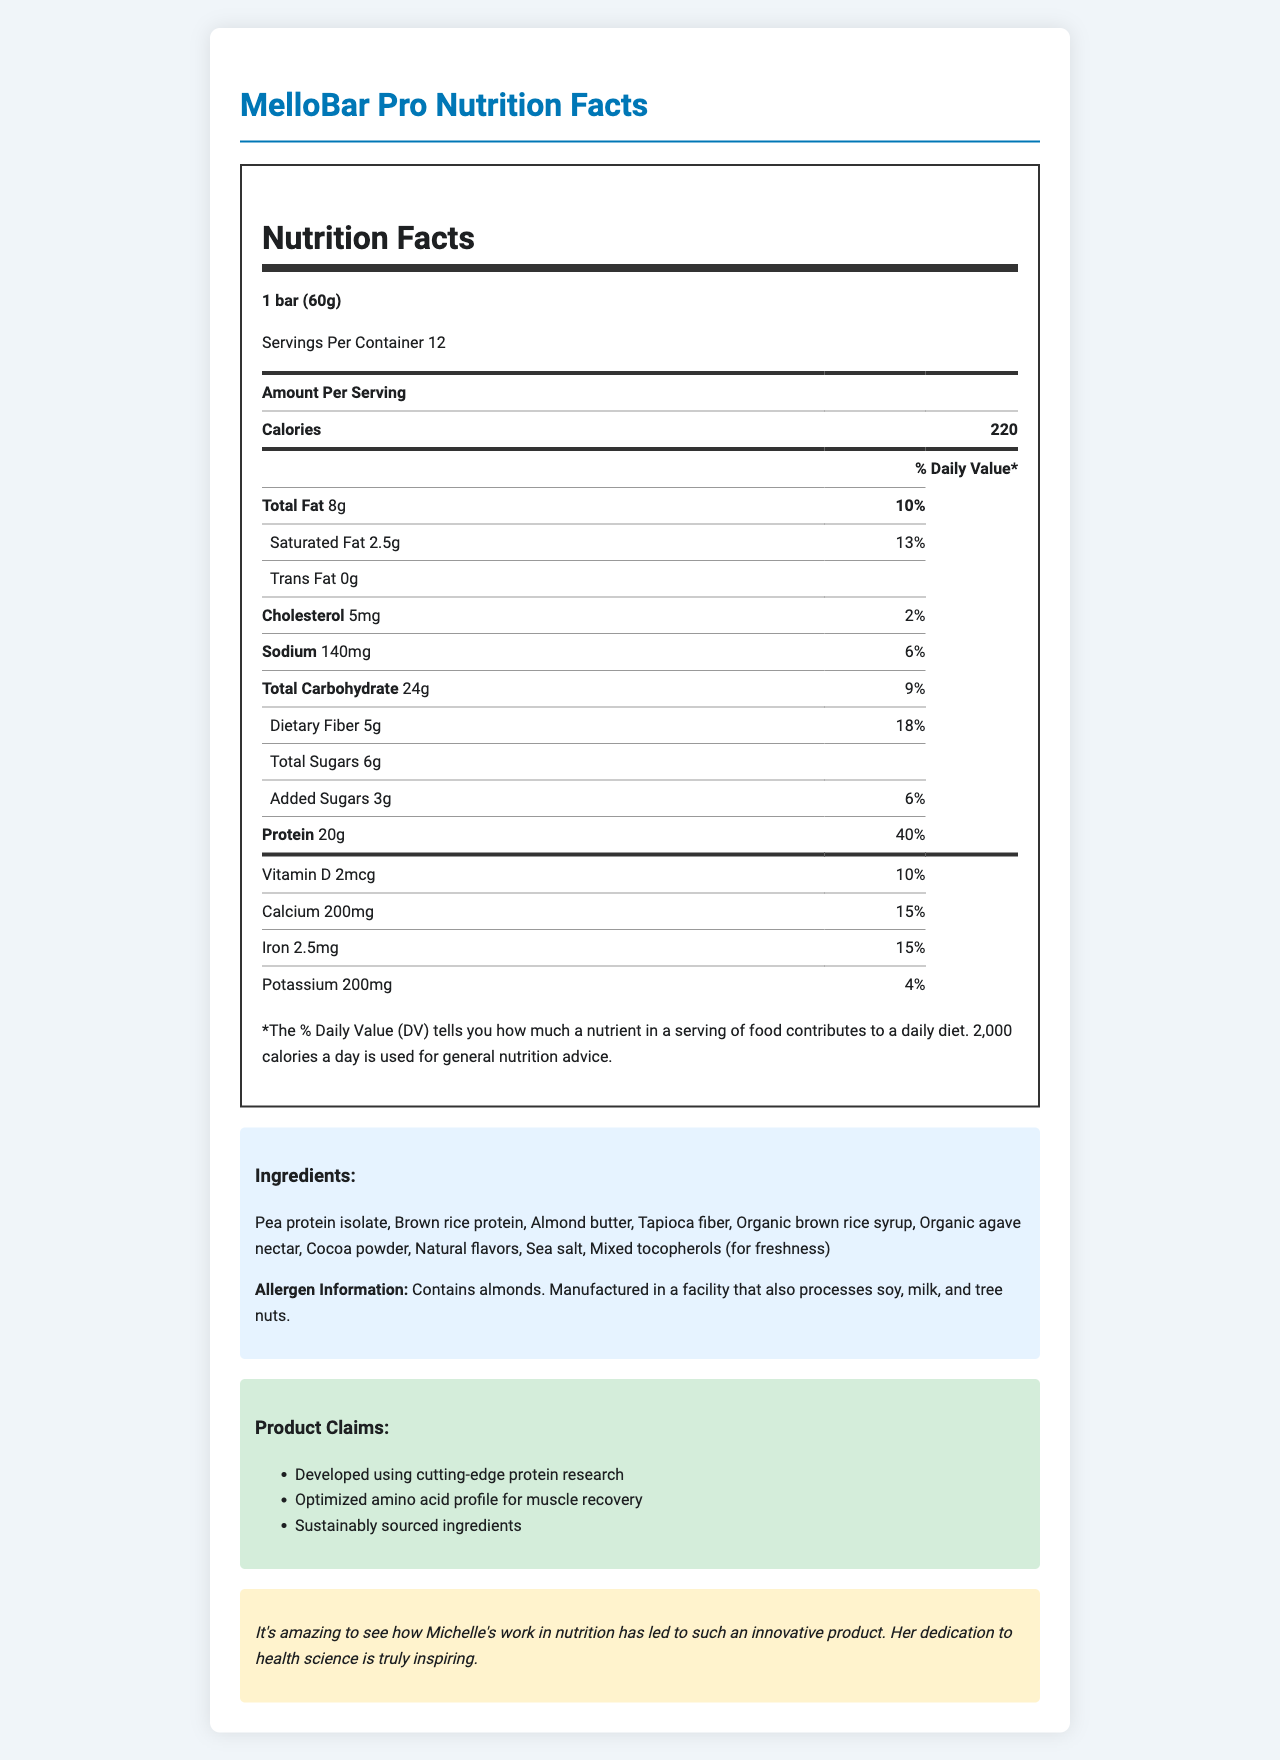what is the serving size of the MelloBar Pro? The document specifies the serving size as "1 bar (60g)".
Answer: 1 bar (60g) how many calories are in one serving? The document states that one serving contains 220 calories.
Answer: 220 what is the total fat content in a serving? The total fat content is listed as "8g" in the document.
Answer: 8g how much protein does the MelloBar Pro contain per serving? The document indicates that each serving contains 20g of protein.
Answer: 20g what allergens are mentioned in the allergen information section? The document mentions that the product contains almonds and is manufactured in a facility that also processes soy, milk, and tree nuts.
Answer: almonds, soy, milk, and tree nuts how much dietary fiber is in a serving of MelloBar Pro? The document specifies that there are 5g of dietary fiber per serving.
Answer: 5g how much vitamin D does MelloBar Pro provide per serving? The document lists vitamin D as "2mcg" with a 10% daily value per serving.
Answer: 2mcg (10% DV) what percentage of the daily value (% DV) does the calcium content in MelloBar Pro represent? The calcium content in a serving represents 15% of the daily value.
Answer: 15% does MelloBar Pro contain any trans fat? The document states "0g" for trans fat, indicating there is none in a serving.
Answer: No which of the following ingredients is NOT in the MelloBar Pro? A. Cocoa powder B. Pea protein isolate C. Whey protein D. Almond butter The ingredient list does not include whey protein; the other options are listed ingredients.
Answer: C. Whey protein what is the daily value percentage for iron provided by a serving of MelloBar Pro? A. 10% B. 15% C. 20% D. 25% The document indicates that a serving of MelloBar Pro provides 15% of the daily value for iron.
Answer: B. 15% is MelloBar Pro developed using cutting-edge protein research? Yes/No The document claims that MelloBar Pro is developed using cutting-edge protein research.
Answer: Yes summarize the main features of the MelloBar Pro nutrition facts label. This summary captures the nutritional content and key features of the MelloBar Pro based on the document.
Answer: The MelloBar Pro is a protein bar with a serving size of 1 bar (60g). Each serving provides 220 calories, 8g of total fat, 24g of carbohydrates (including 5g dietary fiber and 6g total sugars), and 20g of protein. The bar also contains vitamins and minerals such as vitamin D, calcium, iron, and potassium. Notably, it contains almond allergens and is manufactured in a facility that processes soy, milk, and tree nuts. Its ingredients are sustainably sourced, with claims emphasizing its optimized amino acid profile for muscle recovery. what percentage of daily value does total carbohydrate represent in MelloBar Pro? The document mentions that total carbohydrate content represents 9% of the daily value.
Answer: 9% how many servings are there in one container of MelloBar Pro? The document states that there are 12 servings per container.
Answer: 12 who developed the MelloBar Pro? The document does not explicitly mention who developed the product.
Answer: Cannot be determined 